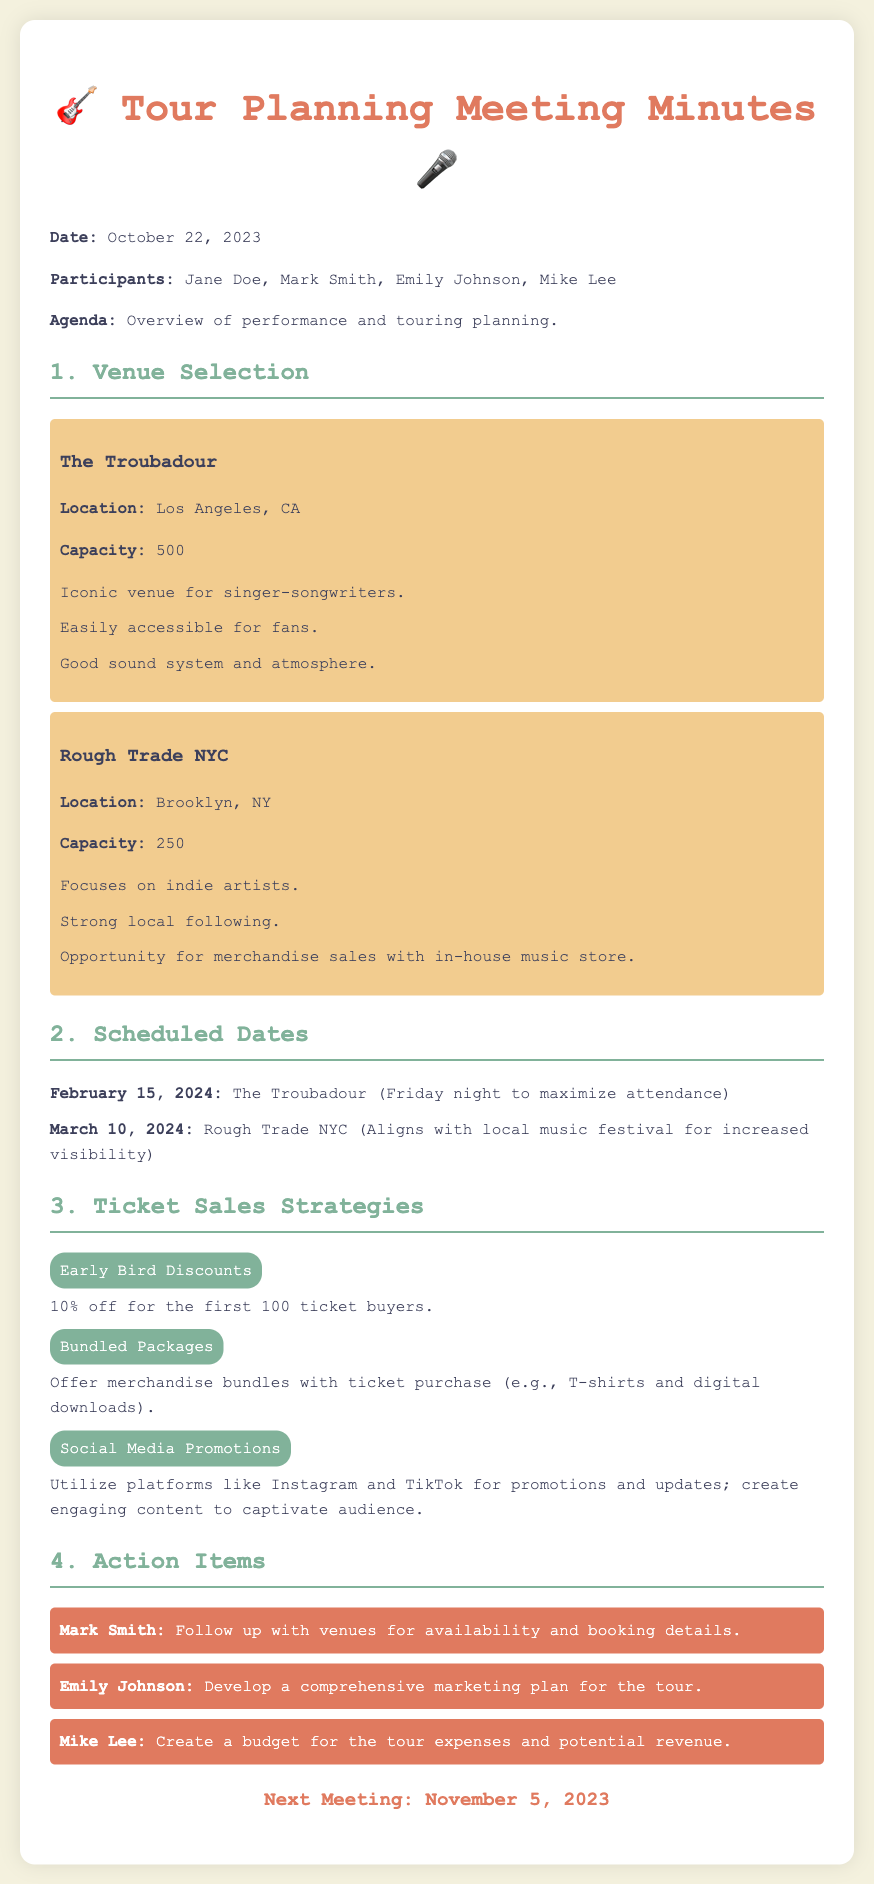what is the date of the meeting? The document states the date of the meeting at the beginning, which is October 22, 2023.
Answer: October 22, 2023 who is responsible for following up with venues? The action item specifies that Mark Smith is tasked with following up with venues for availability and booking details.
Answer: Mark Smith what is the capacity of The Troubadour? The venue section for The Troubadour lists the capacity as 500.
Answer: 500 what is one of the ticket sales strategies mentioned? There are multiple strategies listed, including Early Bird Discounts, so one can be referred to based on the document text.
Answer: Early Bird Discounts when is the next meeting scheduled? The next meeting date is mentioned in the document as November 5, 2023.
Answer: November 5, 2023 why is the date of February 15, 2024, significant? The document mentions that this date is selected for The Troubadour to maximize attendance on a Friday night.
Answer: To maximize attendance which venue focuses on indie artists? The venue Rough Trade NYC is specified to focus on indie artists according to the document.
Answer: Rough Trade NYC what promotional strategy involves social media? The document includes a strategy that specifies the use of social media for promotions and updates.
Answer: Social Media Promotions 